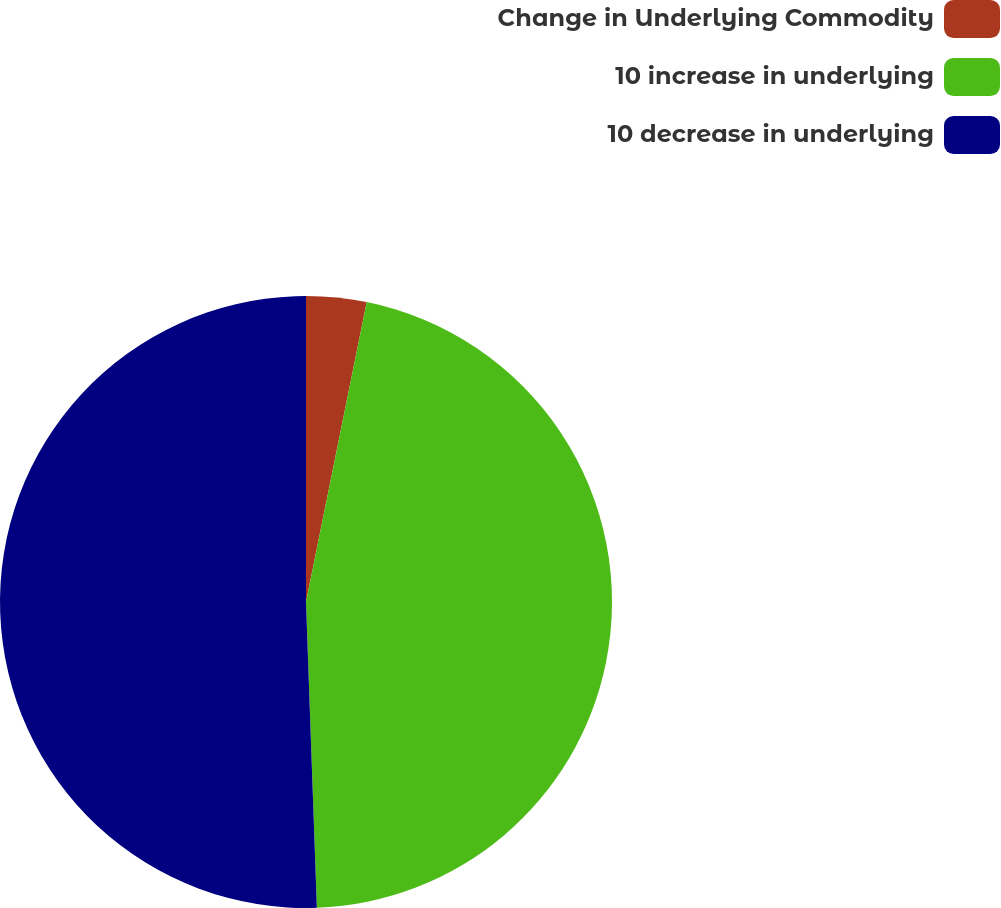Convert chart to OTSL. <chart><loc_0><loc_0><loc_500><loc_500><pie_chart><fcel>Change in Underlying Commodity<fcel>10 increase in underlying<fcel>10 decrease in underlying<nl><fcel>3.18%<fcel>46.25%<fcel>50.56%<nl></chart> 